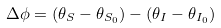Convert formula to latex. <formula><loc_0><loc_0><loc_500><loc_500>\Delta \phi = ( \theta _ { S } - \theta _ { S _ { 0 } } ) - ( \theta _ { I } - \theta _ { I _ { 0 } } )</formula> 